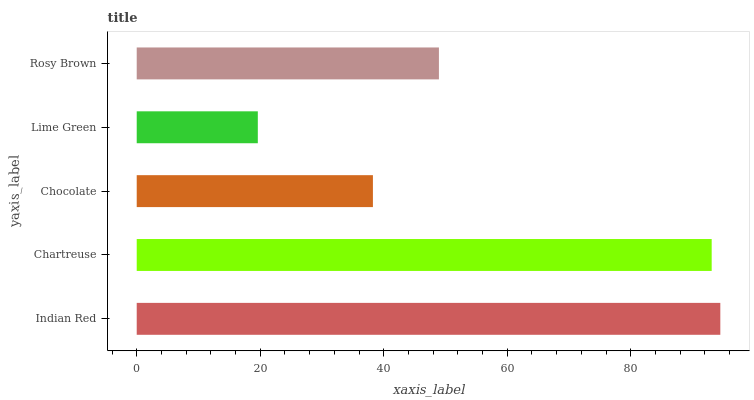Is Lime Green the minimum?
Answer yes or no. Yes. Is Indian Red the maximum?
Answer yes or no. Yes. Is Chartreuse the minimum?
Answer yes or no. No. Is Chartreuse the maximum?
Answer yes or no. No. Is Indian Red greater than Chartreuse?
Answer yes or no. Yes. Is Chartreuse less than Indian Red?
Answer yes or no. Yes. Is Chartreuse greater than Indian Red?
Answer yes or no. No. Is Indian Red less than Chartreuse?
Answer yes or no. No. Is Rosy Brown the high median?
Answer yes or no. Yes. Is Rosy Brown the low median?
Answer yes or no. Yes. Is Indian Red the high median?
Answer yes or no. No. Is Chocolate the low median?
Answer yes or no. No. 